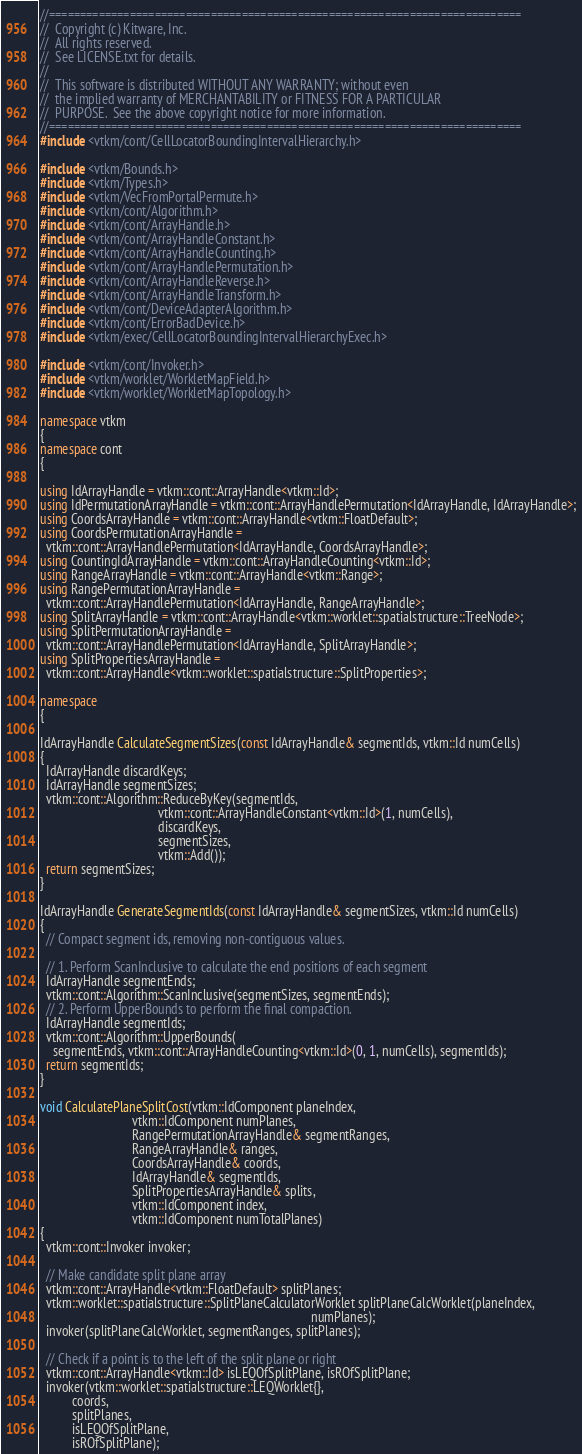<code> <loc_0><loc_0><loc_500><loc_500><_C++_>//============================================================================
//  Copyright (c) Kitware, Inc.
//  All rights reserved.
//  See LICENSE.txt for details.
//
//  This software is distributed WITHOUT ANY WARRANTY; without even
//  the implied warranty of MERCHANTABILITY or FITNESS FOR A PARTICULAR
//  PURPOSE.  See the above copyright notice for more information.
//============================================================================
#include <vtkm/cont/CellLocatorBoundingIntervalHierarchy.h>

#include <vtkm/Bounds.h>
#include <vtkm/Types.h>
#include <vtkm/VecFromPortalPermute.h>
#include <vtkm/cont/Algorithm.h>
#include <vtkm/cont/ArrayHandle.h>
#include <vtkm/cont/ArrayHandleConstant.h>
#include <vtkm/cont/ArrayHandleCounting.h>
#include <vtkm/cont/ArrayHandlePermutation.h>
#include <vtkm/cont/ArrayHandleReverse.h>
#include <vtkm/cont/ArrayHandleTransform.h>
#include <vtkm/cont/DeviceAdapterAlgorithm.h>
#include <vtkm/cont/ErrorBadDevice.h>
#include <vtkm/exec/CellLocatorBoundingIntervalHierarchyExec.h>

#include <vtkm/cont/Invoker.h>
#include <vtkm/worklet/WorkletMapField.h>
#include <vtkm/worklet/WorkletMapTopology.h>

namespace vtkm
{
namespace cont
{

using IdArrayHandle = vtkm::cont::ArrayHandle<vtkm::Id>;
using IdPermutationArrayHandle = vtkm::cont::ArrayHandlePermutation<IdArrayHandle, IdArrayHandle>;
using CoordsArrayHandle = vtkm::cont::ArrayHandle<vtkm::FloatDefault>;
using CoordsPermutationArrayHandle =
  vtkm::cont::ArrayHandlePermutation<IdArrayHandle, CoordsArrayHandle>;
using CountingIdArrayHandle = vtkm::cont::ArrayHandleCounting<vtkm::Id>;
using RangeArrayHandle = vtkm::cont::ArrayHandle<vtkm::Range>;
using RangePermutationArrayHandle =
  vtkm::cont::ArrayHandlePermutation<IdArrayHandle, RangeArrayHandle>;
using SplitArrayHandle = vtkm::cont::ArrayHandle<vtkm::worklet::spatialstructure::TreeNode>;
using SplitPermutationArrayHandle =
  vtkm::cont::ArrayHandlePermutation<IdArrayHandle, SplitArrayHandle>;
using SplitPropertiesArrayHandle =
  vtkm::cont::ArrayHandle<vtkm::worklet::spatialstructure::SplitProperties>;

namespace
{

IdArrayHandle CalculateSegmentSizes(const IdArrayHandle& segmentIds, vtkm::Id numCells)
{
  IdArrayHandle discardKeys;
  IdArrayHandle segmentSizes;
  vtkm::cont::Algorithm::ReduceByKey(segmentIds,
                                     vtkm::cont::ArrayHandleConstant<vtkm::Id>(1, numCells),
                                     discardKeys,
                                     segmentSizes,
                                     vtkm::Add());
  return segmentSizes;
}

IdArrayHandle GenerateSegmentIds(const IdArrayHandle& segmentSizes, vtkm::Id numCells)
{
  // Compact segment ids, removing non-contiguous values.

  // 1. Perform ScanInclusive to calculate the end positions of each segment
  IdArrayHandle segmentEnds;
  vtkm::cont::Algorithm::ScanInclusive(segmentSizes, segmentEnds);
  // 2. Perform UpperBounds to perform the final compaction.
  IdArrayHandle segmentIds;
  vtkm::cont::Algorithm::UpperBounds(
    segmentEnds, vtkm::cont::ArrayHandleCounting<vtkm::Id>(0, 1, numCells), segmentIds);
  return segmentIds;
}

void CalculatePlaneSplitCost(vtkm::IdComponent planeIndex,
                             vtkm::IdComponent numPlanes,
                             RangePermutationArrayHandle& segmentRanges,
                             RangeArrayHandle& ranges,
                             CoordsArrayHandle& coords,
                             IdArrayHandle& segmentIds,
                             SplitPropertiesArrayHandle& splits,
                             vtkm::IdComponent index,
                             vtkm::IdComponent numTotalPlanes)
{
  vtkm::cont::Invoker invoker;

  // Make candidate split plane array
  vtkm::cont::ArrayHandle<vtkm::FloatDefault> splitPlanes;
  vtkm::worklet::spatialstructure::SplitPlaneCalculatorWorklet splitPlaneCalcWorklet(planeIndex,
                                                                                     numPlanes);
  invoker(splitPlaneCalcWorklet, segmentRanges, splitPlanes);

  // Check if a point is to the left of the split plane or right
  vtkm::cont::ArrayHandle<vtkm::Id> isLEQOfSplitPlane, isROfSplitPlane;
  invoker(vtkm::worklet::spatialstructure::LEQWorklet{},
          coords,
          splitPlanes,
          isLEQOfSplitPlane,
          isROfSplitPlane);
</code> 